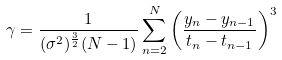Convert formula to latex. <formula><loc_0><loc_0><loc_500><loc_500>\gamma = \frac { 1 } { ( \sigma ^ { 2 } ) ^ { \frac { 3 } { 2 } } ( N - 1 ) } \sum _ { n = 2 } ^ { N } \left ( \frac { y _ { n } - y _ { n - 1 } } { t _ { n } - t _ { n - 1 } } \right ) ^ { 3 }</formula> 